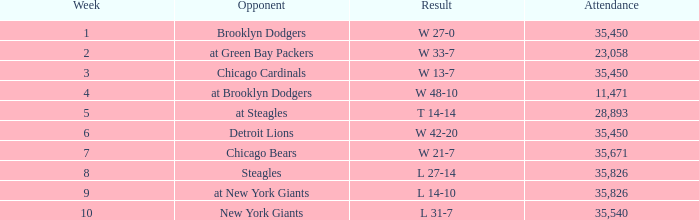How many attendances have w 48-10 as the result? 11471.0. 